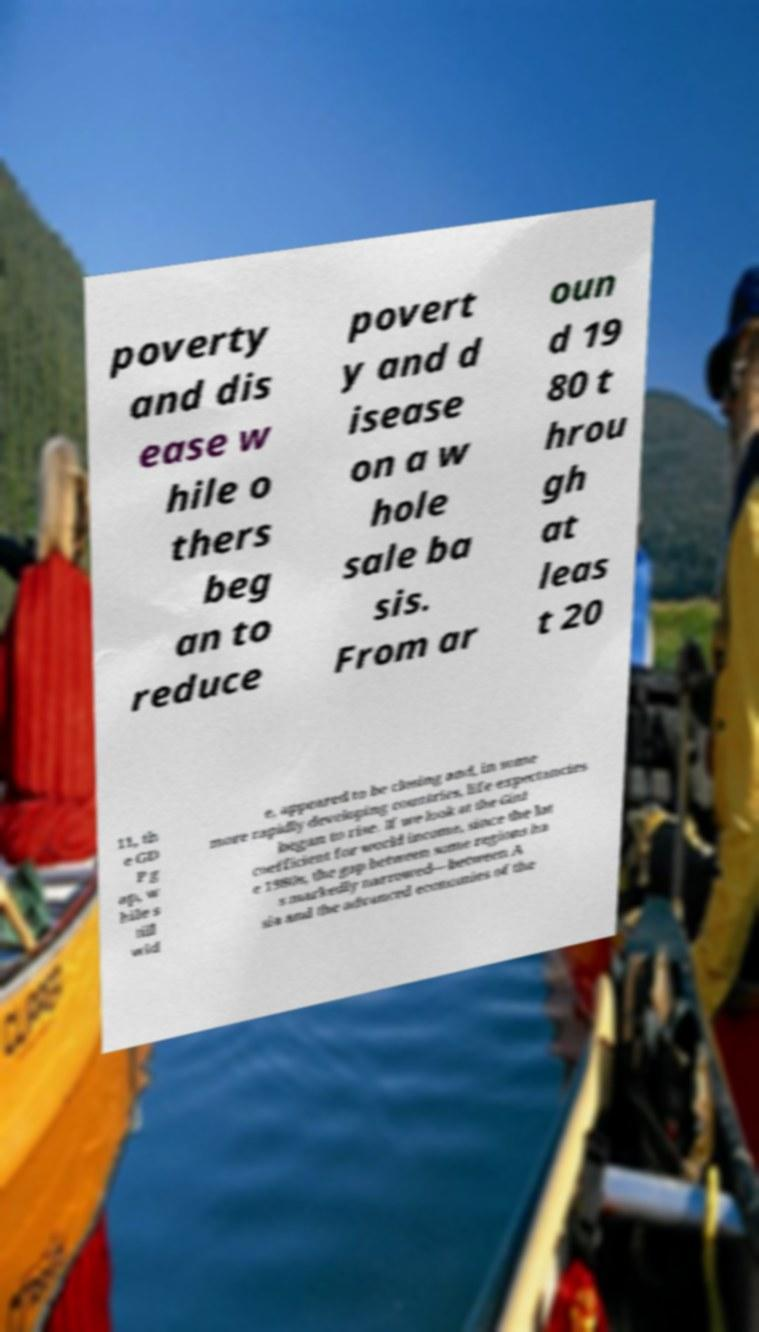For documentation purposes, I need the text within this image transcribed. Could you provide that? poverty and dis ease w hile o thers beg an to reduce povert y and d isease on a w hole sale ba sis. From ar oun d 19 80 t hrou gh at leas t 20 11, th e GD P g ap, w hile s till wid e, appeared to be closing and, in some more rapidly developing countries, life expectancies began to rise. If we look at the Gini coefficient for world income, since the lat e 1980s, the gap between some regions ha s markedly narrowed—between A sia and the advanced economies of the 